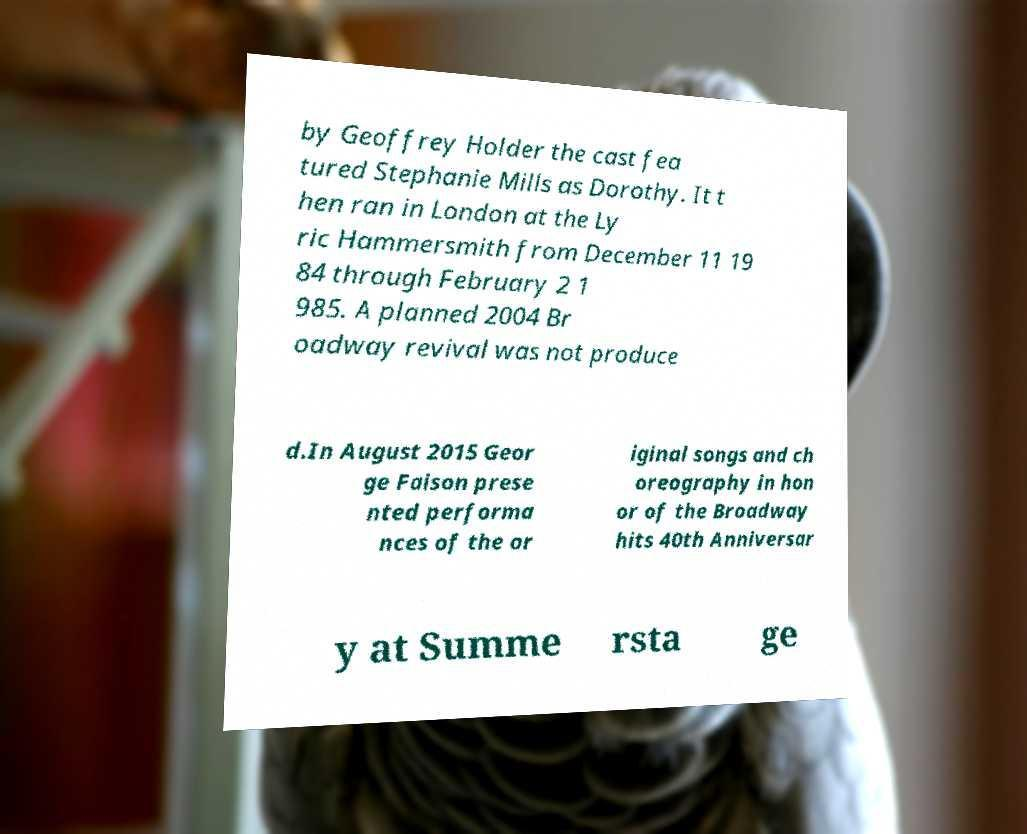Please read and relay the text visible in this image. What does it say? by Geoffrey Holder the cast fea tured Stephanie Mills as Dorothy. It t hen ran in London at the Ly ric Hammersmith from December 11 19 84 through February 2 1 985. A planned 2004 Br oadway revival was not produce d.In August 2015 Geor ge Faison prese nted performa nces of the or iginal songs and ch oreography in hon or of the Broadway hits 40th Anniversar y at Summe rsta ge 